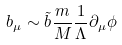Convert formula to latex. <formula><loc_0><loc_0><loc_500><loc_500>b _ { \mu } \sim \tilde { b } \frac { m } { M } \frac { 1 } { \Lambda } \partial _ { \mu } \phi</formula> 